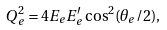<formula> <loc_0><loc_0><loc_500><loc_500>Q ^ { 2 } _ { e } = 4 E _ { e } E _ { e } ^ { \prime } \cos ^ { 2 } ( \theta _ { e } / 2 ) ,</formula> 